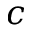<formula> <loc_0><loc_0><loc_500><loc_500>c</formula> 